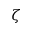<formula> <loc_0><loc_0><loc_500><loc_500>\zeta</formula> 